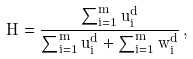<formula> <loc_0><loc_0><loc_500><loc_500>H = { \frac { \sum _ { i = 1 } ^ { m } { u _ { i } ^ { d } } } { \sum _ { i = 1 } ^ { m } { u _ { i } ^ { d } } + \sum _ { i = 1 } ^ { m } { w _ { i } ^ { d } } } } \, ,</formula> 